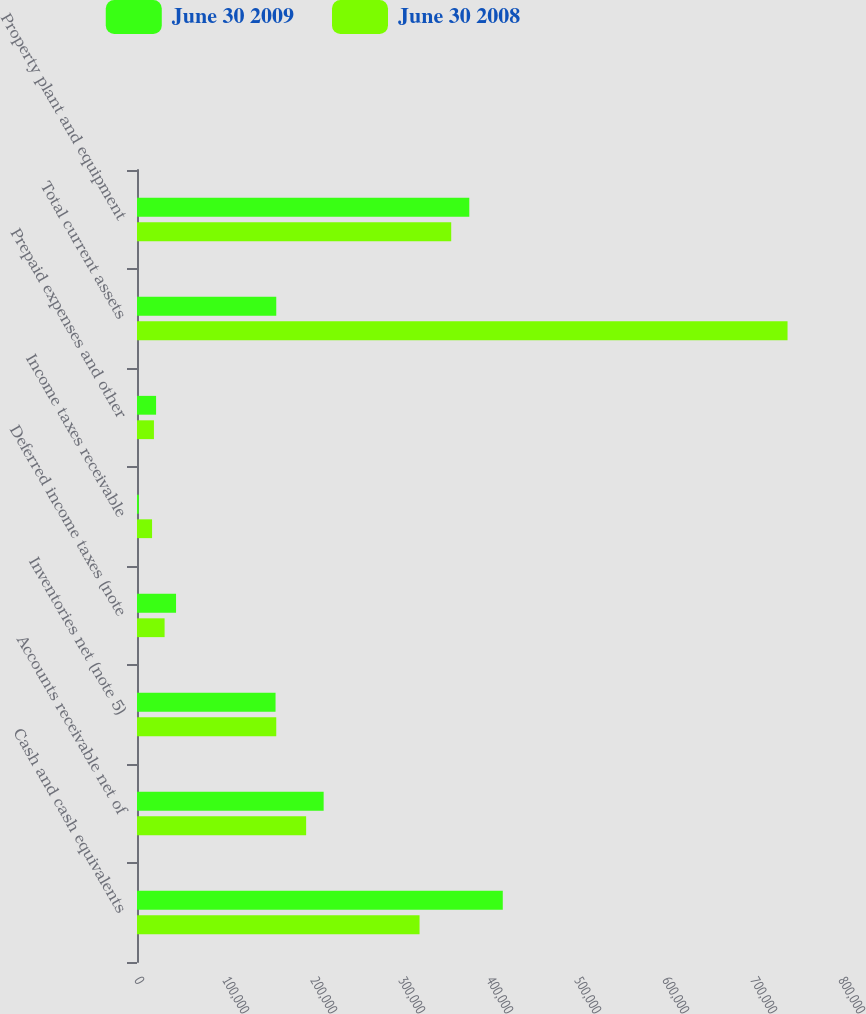Convert chart to OTSL. <chart><loc_0><loc_0><loc_500><loc_500><stacked_bar_chart><ecel><fcel>Cash and cash equivalents<fcel>Accounts receivable net of<fcel>Inventories net (note 5)<fcel>Deferred income taxes (note<fcel>Income taxes receivable<fcel>Prepaid expenses and other<fcel>Total current assets<fcel>Property plant and equipment<nl><fcel>June 30 2009<fcel>415650<fcel>212096<fcel>157431<fcel>44368<fcel>2067<fcel>21672<fcel>158251<fcel>377613<nl><fcel>June 30 2008<fcel>321078<fcel>192200<fcel>158251<fcel>31355<fcel>17115<fcel>19241<fcel>739240<fcel>357057<nl></chart> 